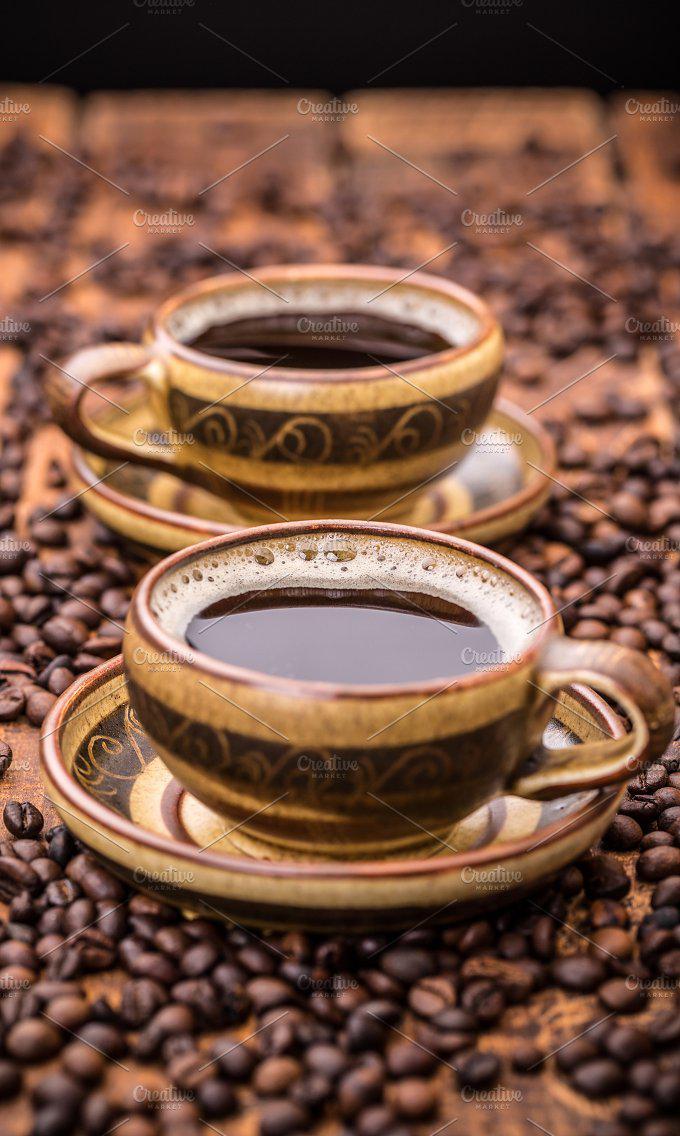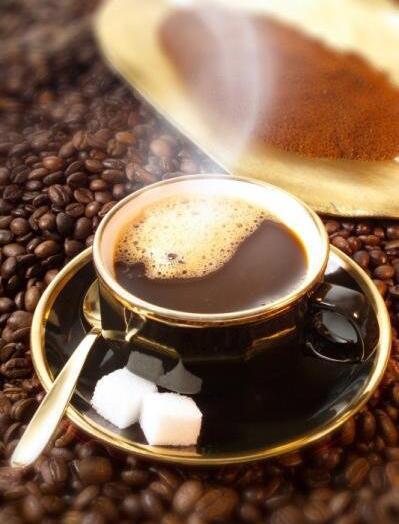The first image is the image on the left, the second image is the image on the right. Evaluate the accuracy of this statement regarding the images: "An image shows one hot beverage in a cup on a saucer that holds a spoon.". Is it true? Answer yes or no. Yes. The first image is the image on the left, the second image is the image on the right. Given the left and right images, does the statement "There are three cups of coffee on three saucers." hold true? Answer yes or no. Yes. 